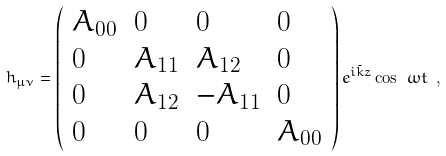<formula> <loc_0><loc_0><loc_500><loc_500>h _ { \mu \nu } = \left ( \begin{array} { l l l l } A _ { 0 0 } & 0 & 0 & 0 \\ 0 & A _ { 1 1 } & A _ { 1 2 } & 0 \\ 0 & A _ { 1 2 } & - A _ { 1 1 } & 0 \\ 0 & 0 & 0 & A _ { 0 0 } \end{array} \right ) e ^ { i \tilde { k } z } \cos \ \omega t \ ,</formula> 